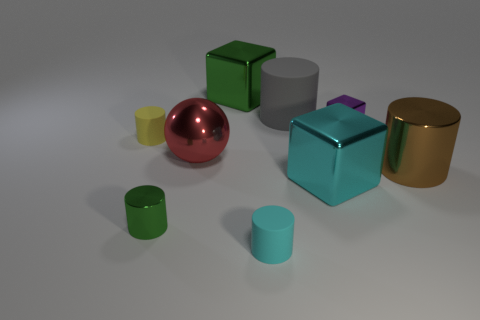There is a big object that is the same color as the tiny shiny cylinder; what is its material?
Offer a very short reply. Metal. What is the color of the tiny thing that is the same material as the green cylinder?
Your answer should be compact. Purple. Are there any big red spheres that have the same material as the small block?
Offer a very short reply. Yes. There is a cylinder in front of the small metallic object that is in front of the sphere; what size is it?
Keep it short and to the point. Small. Are there more brown cylinders than things?
Keep it short and to the point. No. Is the size of the object to the right of the purple shiny object the same as the yellow matte object?
Provide a succinct answer. No. What number of tiny things are the same color as the large matte thing?
Provide a short and direct response. 0. Is the shape of the small green metallic object the same as the yellow thing?
Give a very brief answer. Yes. The gray thing that is the same shape as the big brown object is what size?
Provide a succinct answer. Large. Is the number of red metal spheres behind the small green metal cylinder greater than the number of large red shiny things that are in front of the cyan rubber cylinder?
Offer a terse response. Yes. 